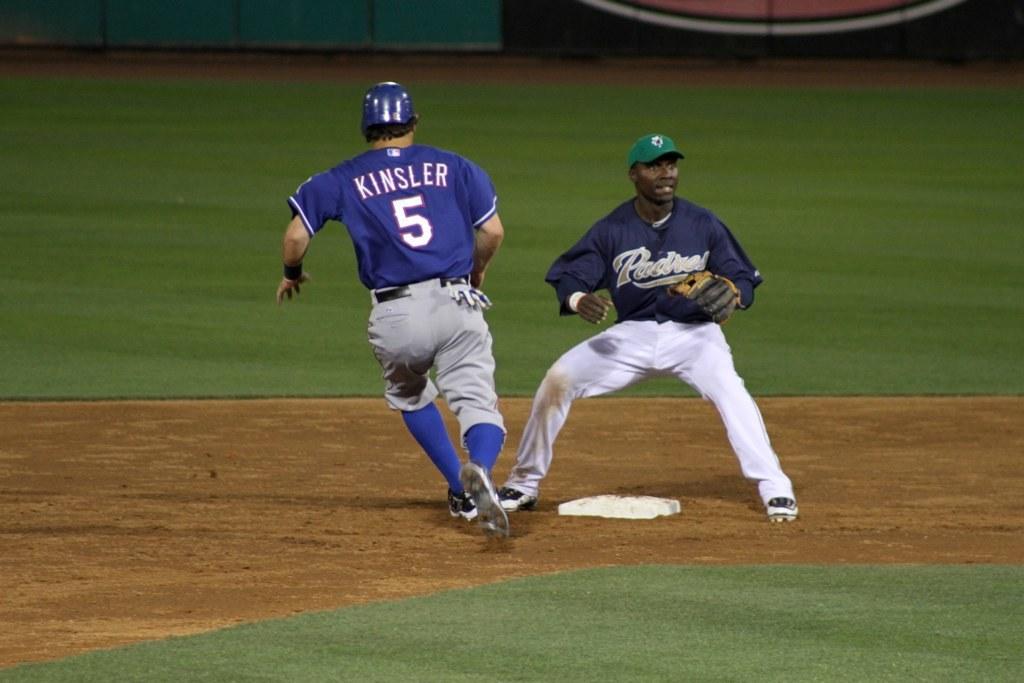What is the number on the blue jersey?
Provide a succinct answer. 5. 